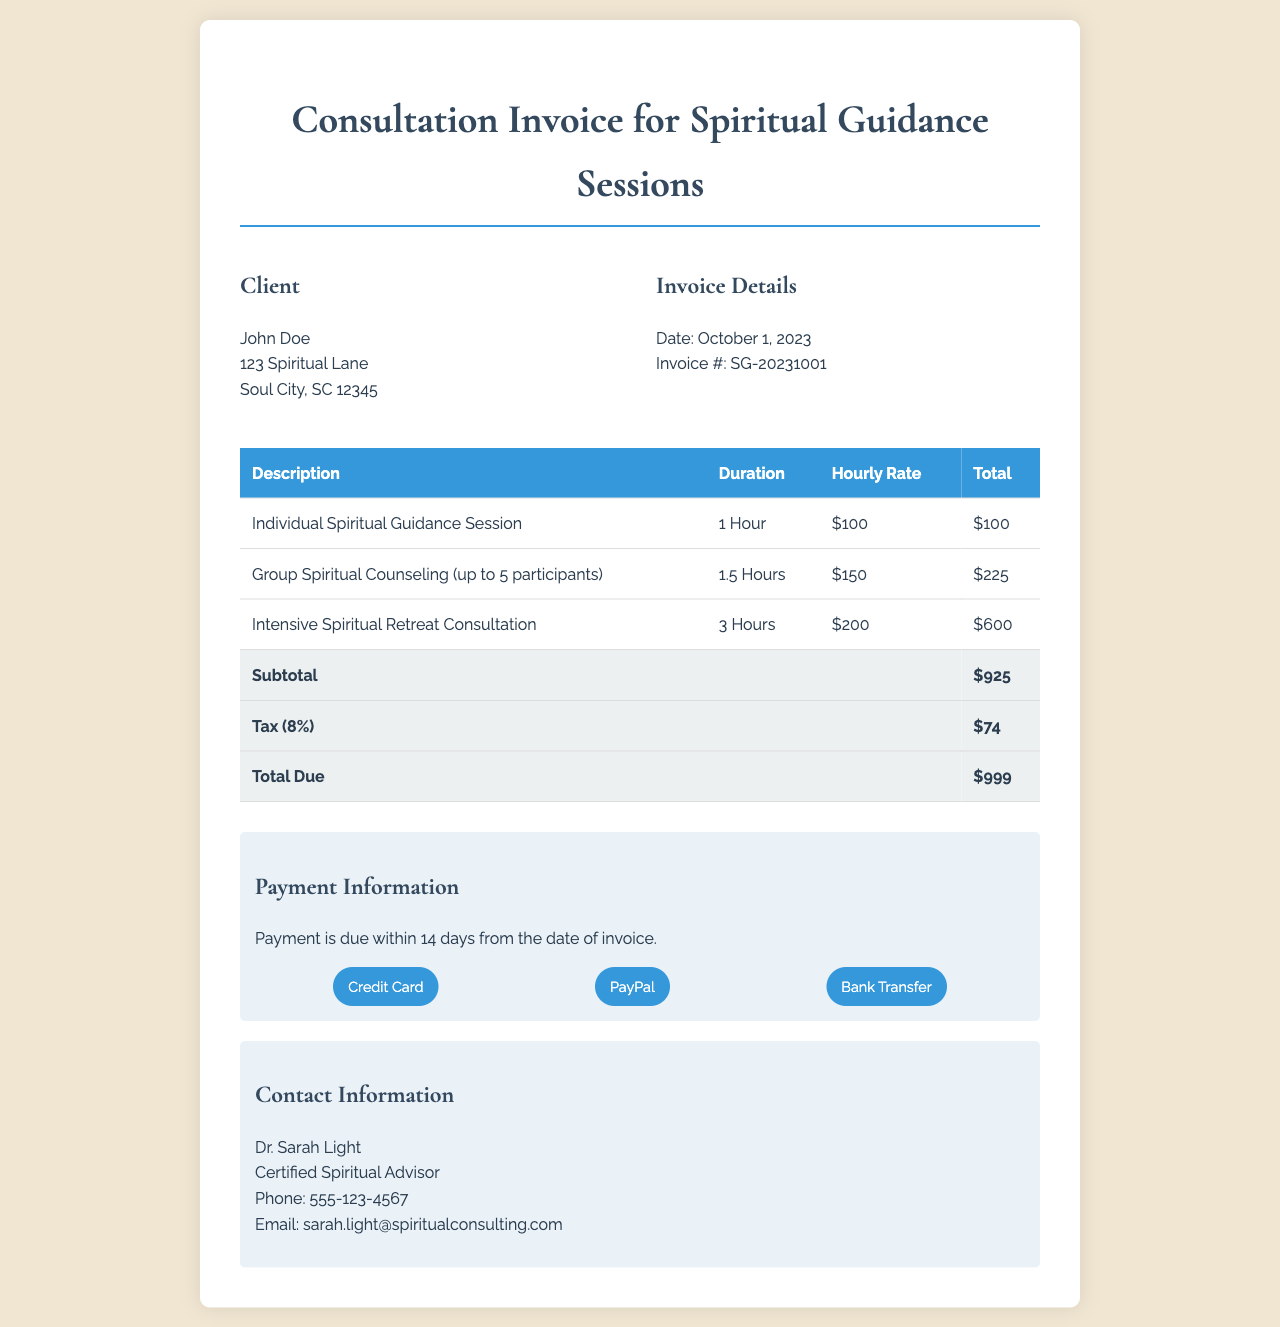What is the name of the client? The document includes the name of the client at the beginning, which is John Doe.
Answer: John Doe What is the invoice number? The invoice number is specified in the invoice details section, listed as SG-20231001.
Answer: SG-20231001 What is the hourly rate for the Individual Spiritual Guidance Session? The document shows the hourly rate for the Individual Spiritual Guidance Session is $100.
Answer: $100 How long is the Group Spiritual Counseling session? The duration of the Group Spiritual Counseling session is indicated in the table as 1.5 Hours.
Answer: 1.5 Hours What is the subtotal before tax? The subtotal is presented in the total row of the invoice, calculated as $925 before tax.
Answer: $925 What is the total amount due including tax? The total due is found in the final total row of the document, which is $999.
Answer: $999 What is the tax percentage applied? The tax percentage is mentioned as 8% in the breakdown of costs in the document.
Answer: 8% Who is the certified spiritual advisor? The certified spiritual advisor's name is given at the bottom of the document as Dr. Sarah Light.
Answer: Dr. Sarah Light What are the payment methods accepted? The invoice lists the payment methods accepted which include Credit Card, PayPal, and Bank Transfer.
Answer: Credit Card, PayPal, Bank Transfer 